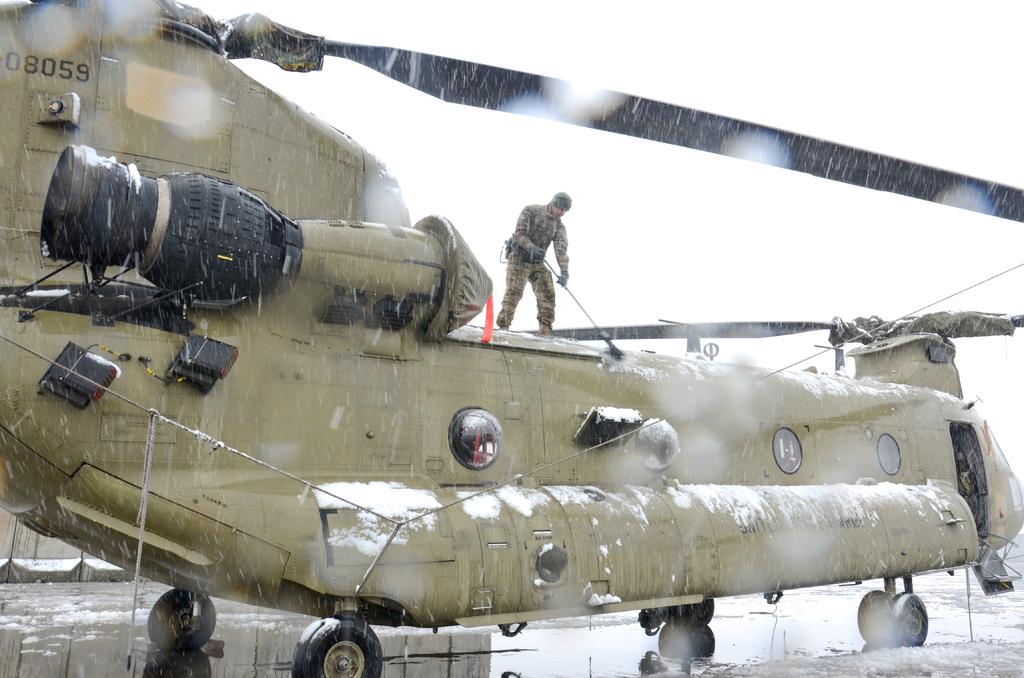What is the call number of the helicopter?
Ensure brevity in your answer.  08059. What is written on the plane?
Provide a short and direct response. 08059. 